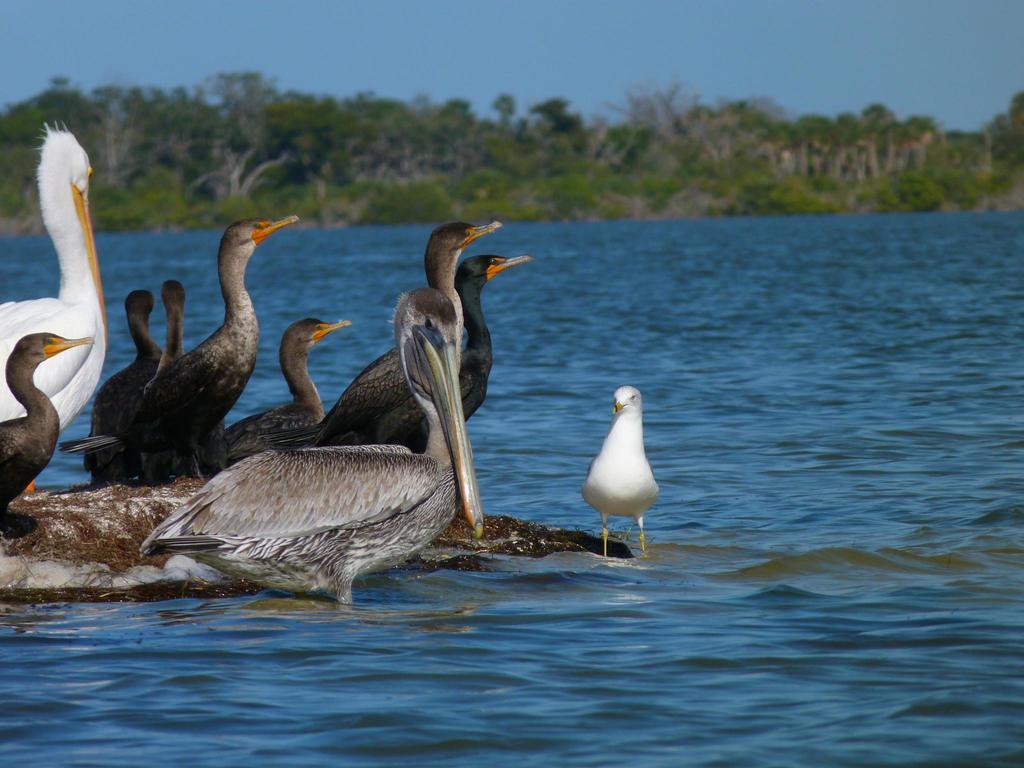Describe this image in one or two sentences. In the image we can see there are many ducks of different colors. Here we can see the water, trees, plants and the sky. 